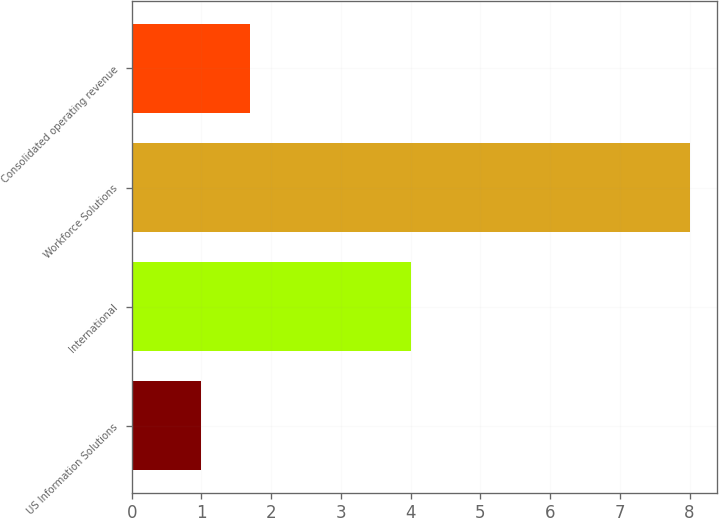<chart> <loc_0><loc_0><loc_500><loc_500><bar_chart><fcel>US Information Solutions<fcel>International<fcel>Workforce Solutions<fcel>Consolidated operating revenue<nl><fcel>1<fcel>4<fcel>8<fcel>1.7<nl></chart> 